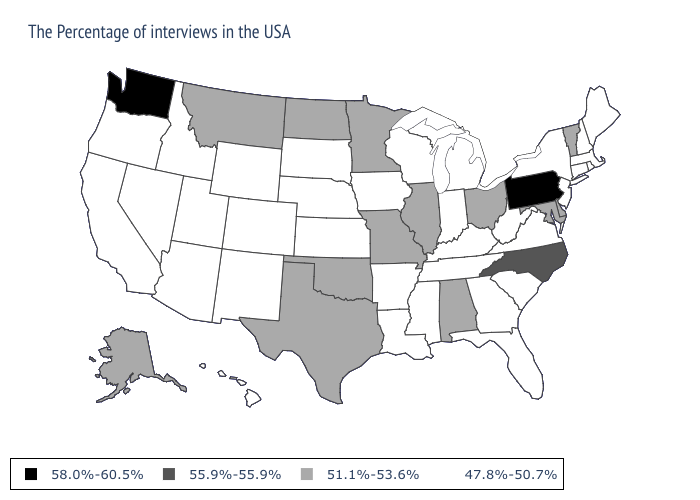What is the value of Florida?
Write a very short answer. 47.8%-50.7%. Name the states that have a value in the range 47.8%-50.7%?
Concise answer only. Maine, Massachusetts, Rhode Island, New Hampshire, Connecticut, New York, New Jersey, Virginia, South Carolina, West Virginia, Florida, Georgia, Michigan, Kentucky, Indiana, Tennessee, Wisconsin, Mississippi, Louisiana, Arkansas, Iowa, Kansas, Nebraska, South Dakota, Wyoming, Colorado, New Mexico, Utah, Arizona, Idaho, Nevada, California, Oregon, Hawaii. Which states have the lowest value in the West?
Quick response, please. Wyoming, Colorado, New Mexico, Utah, Arizona, Idaho, Nevada, California, Oregon, Hawaii. Name the states that have a value in the range 55.9%-55.9%?
Short answer required. North Carolina. Is the legend a continuous bar?
Answer briefly. No. Name the states that have a value in the range 55.9%-55.9%?
Short answer required. North Carolina. Does Maryland have the same value as Nevada?
Write a very short answer. No. Does the first symbol in the legend represent the smallest category?
Be succinct. No. Name the states that have a value in the range 47.8%-50.7%?
Quick response, please. Maine, Massachusetts, Rhode Island, New Hampshire, Connecticut, New York, New Jersey, Virginia, South Carolina, West Virginia, Florida, Georgia, Michigan, Kentucky, Indiana, Tennessee, Wisconsin, Mississippi, Louisiana, Arkansas, Iowa, Kansas, Nebraska, South Dakota, Wyoming, Colorado, New Mexico, Utah, Arizona, Idaho, Nevada, California, Oregon, Hawaii. Does Mississippi have a lower value than Nevada?
Quick response, please. No. What is the highest value in states that border Utah?
Quick response, please. 47.8%-50.7%. What is the value of Rhode Island?
Answer briefly. 47.8%-50.7%. Does Washington have the highest value in the USA?
Give a very brief answer. Yes. Does Oregon have the highest value in the USA?
Concise answer only. No. 